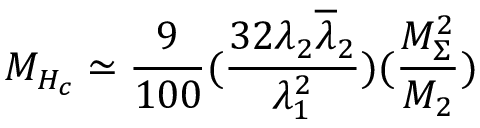<formula> <loc_0><loc_0><loc_500><loc_500>M _ { H _ { c } } \simeq \frac { 9 } { 1 0 0 } ( \frac { 3 2 \lambda _ { 2 } \overline { \lambda } _ { 2 } } { \lambda _ { 1 } ^ { 2 } } ) ( \frac { M _ { \Sigma } ^ { 2 } } { M _ { 2 } } )</formula> 